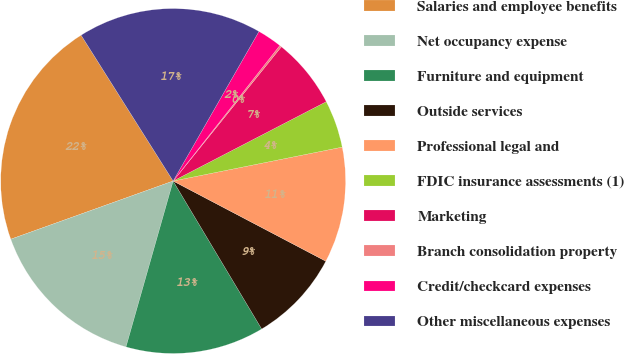Convert chart to OTSL. <chart><loc_0><loc_0><loc_500><loc_500><pie_chart><fcel>Salaries and employee benefits<fcel>Net occupancy expense<fcel>Furniture and equipment<fcel>Outside services<fcel>Professional legal and<fcel>FDIC insurance assessments (1)<fcel>Marketing<fcel>Branch consolidation property<fcel>Credit/checkcard expenses<fcel>Other miscellaneous expenses<nl><fcel>21.52%<fcel>15.12%<fcel>12.99%<fcel>8.72%<fcel>10.85%<fcel>4.46%<fcel>6.59%<fcel>0.19%<fcel>2.32%<fcel>17.25%<nl></chart> 